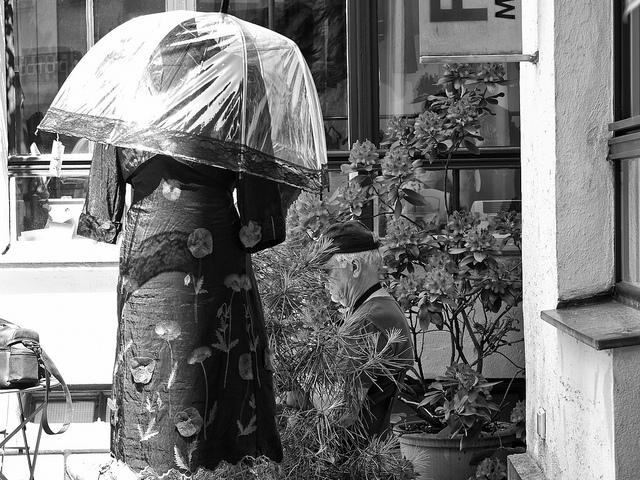Why no hands or head?

Choices:
A) cut off
B) small limbs
C) is mannequin
D) under dress is mannequin 